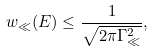<formula> <loc_0><loc_0><loc_500><loc_500>w _ { \ll } ( E ) \leq \frac { 1 } { \sqrt { 2 \pi \Gamma _ { \ll } ^ { 2 } } } ,</formula> 